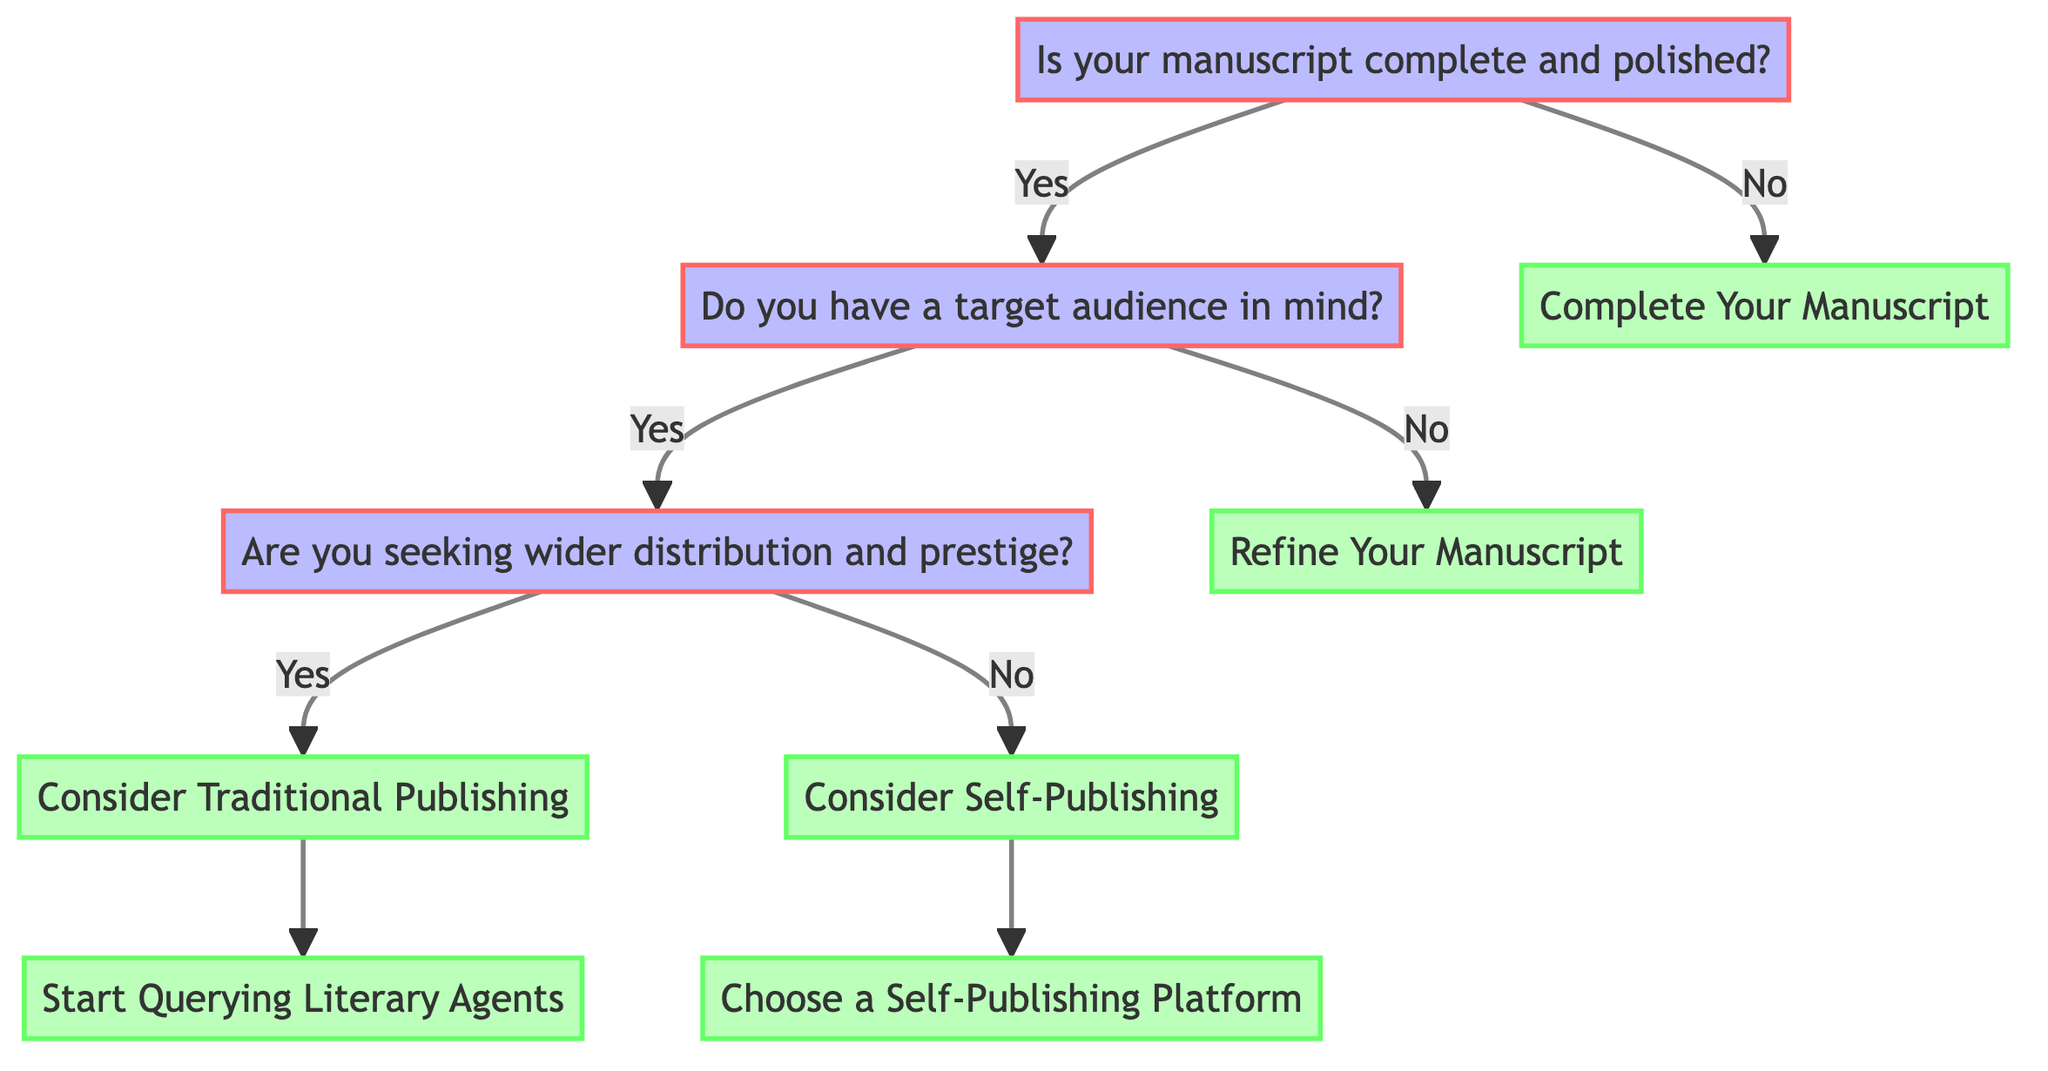What is the first question in the diagram? The first question in the diagram is found at the topmost node, which asks, "Is your manuscript complete and polished?"
Answer: Is your manuscript complete and polished? If your manuscript is not complete, what is the next step? If the manuscript is not complete, the diagram indicates that the next step is "Complete Your Manuscript."
Answer: Complete Your Manuscript How many options are available if the answer to "Do you have a target audience in mind?" is yes? If the answer to this question is yes, there are two options: "Are you seeking wider distribution and prestige?" and an option for further steps related to traditional or self-publishing.
Answer: 2 options What are the advantages of choosing traditional publishing? The advantages of traditional publishing include professional editing services, established distribution channels, and advance payments and royalties.
Answer: Professional editing services, established distribution channels, advance payments and royalties What should you do if you want to self-publish? If you want to self-publish, the diagram suggests that you should "Choose a Self-Publishing Platform."
Answer: Choose a Self-Publishing Platform What does the diagram suggest if you do not have a target audience? If there is no target audience defined, the diagram indicates that you should "Refine Your Manuscript."
Answer: Refine Your Manuscript What are the disadvantages of self-publishing mentioned in the diagram? The disadvantages of self-publishing include upfront costs for editing, cover design, responsibility for marketing and distribution, and less prestige in the literary community.
Answer: Upfront costs, responsibility for marketing, less prestige How does one transition from traditional publishing to querying literary agents? After considering traditional publishing, the next step in the diagram is to "Start Querying Literary Agents," which indicates the process to engage with agents.
Answer: Start Querying Literary Agents What is a potential step to complete your manuscript? A potential step to complete your manuscript includes setting a writing schedule.
Answer: Set a writing schedule 